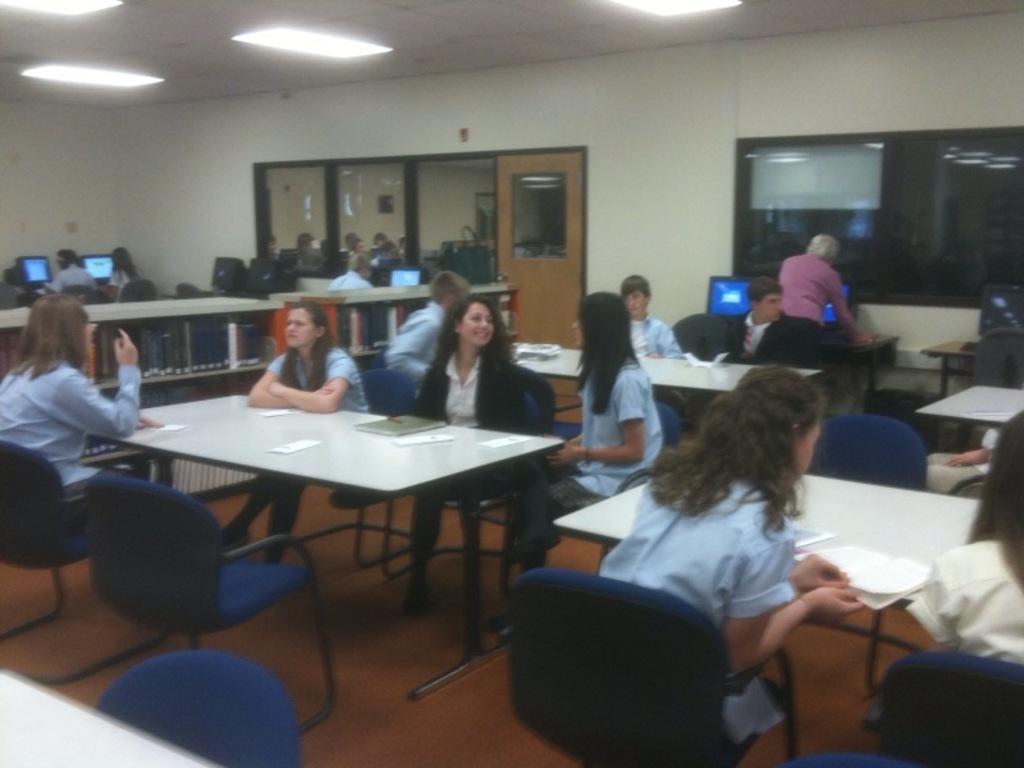Could you give a brief overview of what you see in this image? In this image there are group of people sitting on the chair,in front of the people there is a table and there are book rack. At the background we can see a door. There is a system on the table. 